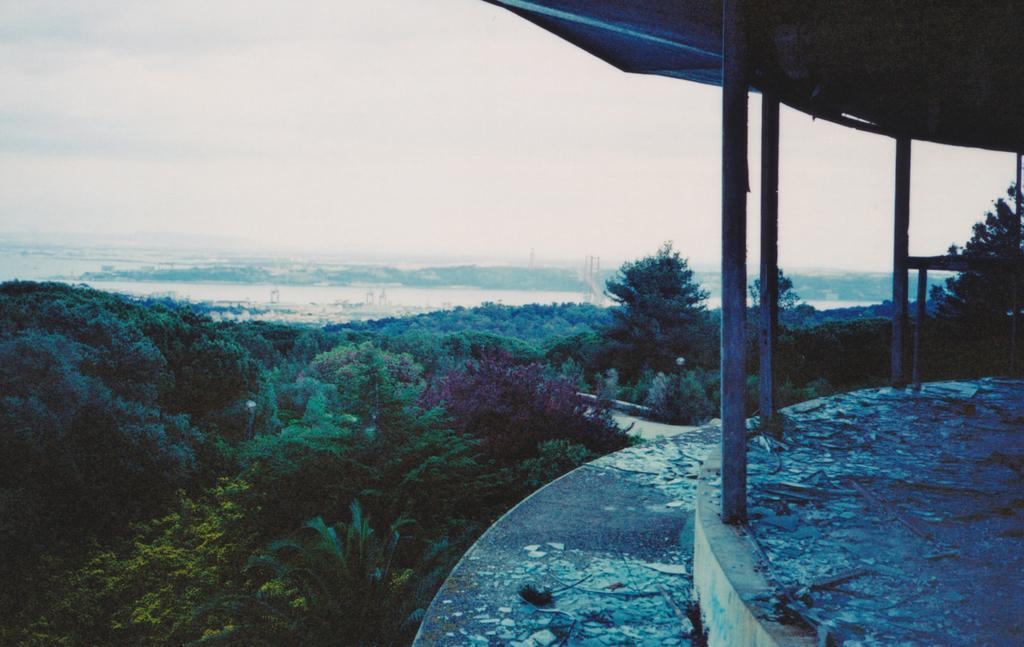Can you describe this image briefly? This image is taken outdoors. At the top of the image there is a sky with clouds. In the middle of the image there are many trees and plants. On the right side of the image there is a picnic spot with a roof. 